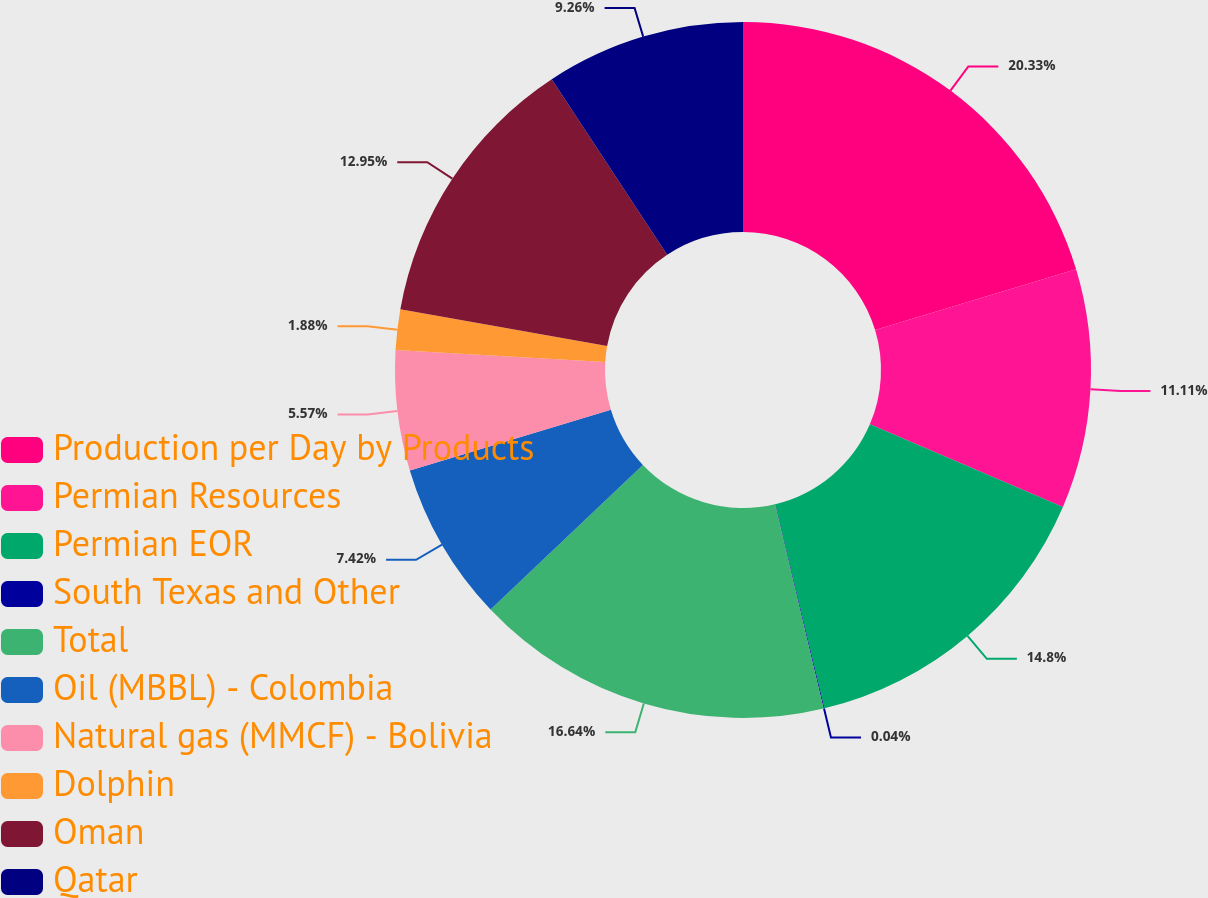Convert chart. <chart><loc_0><loc_0><loc_500><loc_500><pie_chart><fcel>Production per Day by Products<fcel>Permian Resources<fcel>Permian EOR<fcel>South Texas and Other<fcel>Total<fcel>Oil (MBBL) - Colombia<fcel>Natural gas (MMCF) - Bolivia<fcel>Dolphin<fcel>Oman<fcel>Qatar<nl><fcel>20.33%<fcel>11.11%<fcel>14.8%<fcel>0.04%<fcel>16.64%<fcel>7.42%<fcel>5.57%<fcel>1.88%<fcel>12.95%<fcel>9.26%<nl></chart> 